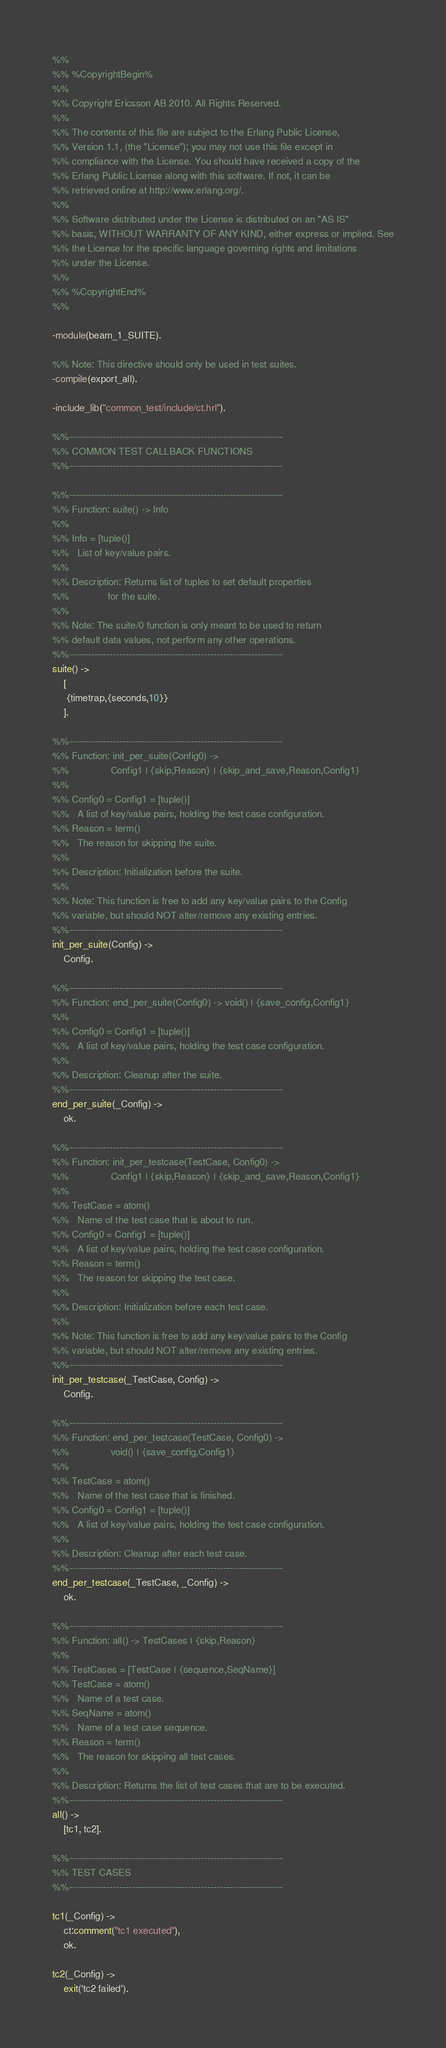<code> <loc_0><loc_0><loc_500><loc_500><_Erlang_>%%
%% %CopyrightBegin%
%%
%% Copyright Ericsson AB 2010. All Rights Reserved.
%%
%% The contents of this file are subject to the Erlang Public License,
%% Version 1.1, (the "License"); you may not use this file except in
%% compliance with the License. You should have received a copy of the
%% Erlang Public License along with this software. If not, it can be
%% retrieved online at http://www.erlang.org/.
%%
%% Software distributed under the License is distributed on an "AS IS"
%% basis, WITHOUT WARRANTY OF ANY KIND, either express or implied. See
%% the License for the specific language governing rights and limitations
%% under the License.
%%
%% %CopyrightEnd%
%%

-module(beam_1_SUITE).

%% Note: This directive should only be used in test suites.
-compile(export_all).

-include_lib("common_test/include/ct.hrl").

%%--------------------------------------------------------------------
%% COMMON TEST CALLBACK FUNCTIONS
%%--------------------------------------------------------------------

%%--------------------------------------------------------------------
%% Function: suite() -> Info
%%
%% Info = [tuple()]
%%   List of key/value pairs.
%%
%% Description: Returns list of tuples to set default properties
%%              for the suite.
%%
%% Note: The suite/0 function is only meant to be used to return
%% default data values, not perform any other operations.
%%--------------------------------------------------------------------
suite() ->
    [
     {timetrap,{seconds,10}}
    ].

%%--------------------------------------------------------------------
%% Function: init_per_suite(Config0) ->
%%               Config1 | {skip,Reason} | {skip_and_save,Reason,Config1}
%%
%% Config0 = Config1 = [tuple()]
%%   A list of key/value pairs, holding the test case configuration.
%% Reason = term()
%%   The reason for skipping the suite.
%%
%% Description: Initialization before the suite.
%%
%% Note: This function is free to add any key/value pairs to the Config
%% variable, but should NOT alter/remove any existing entries.
%%--------------------------------------------------------------------
init_per_suite(Config) ->
    Config.

%%--------------------------------------------------------------------
%% Function: end_per_suite(Config0) -> void() | {save_config,Config1}
%%
%% Config0 = Config1 = [tuple()]
%%   A list of key/value pairs, holding the test case configuration.
%%
%% Description: Cleanup after the suite.
%%--------------------------------------------------------------------
end_per_suite(_Config) ->
    ok.

%%--------------------------------------------------------------------
%% Function: init_per_testcase(TestCase, Config0) ->
%%               Config1 | {skip,Reason} | {skip_and_save,Reason,Config1}
%%
%% TestCase = atom()
%%   Name of the test case that is about to run.
%% Config0 = Config1 = [tuple()]
%%   A list of key/value pairs, holding the test case configuration.
%% Reason = term()
%%   The reason for skipping the test case.
%%
%% Description: Initialization before each test case.
%%
%% Note: This function is free to add any key/value pairs to the Config
%% variable, but should NOT alter/remove any existing entries.
%%--------------------------------------------------------------------
init_per_testcase(_TestCase, Config) ->
    Config.

%%--------------------------------------------------------------------
%% Function: end_per_testcase(TestCase, Config0) ->
%%               void() | {save_config,Config1}
%%
%% TestCase = atom()
%%   Name of the test case that is finished.
%% Config0 = Config1 = [tuple()]
%%   A list of key/value pairs, holding the test case configuration.
%%
%% Description: Cleanup after each test case.
%%--------------------------------------------------------------------
end_per_testcase(_TestCase, _Config) ->
    ok.

%%--------------------------------------------------------------------
%% Function: all() -> TestCases | {skip,Reason}
%%
%% TestCases = [TestCase | {sequence,SeqName}]
%% TestCase = atom()
%%   Name of a test case.
%% SeqName = atom()
%%   Name of a test case sequence.
%% Reason = term()
%%   The reason for skipping all test cases.
%%
%% Description: Returns the list of test cases that are to be executed.
%%--------------------------------------------------------------------
all() ->
    [tc1, tc2].

%%--------------------------------------------------------------------
%% TEST CASES
%%--------------------------------------------------------------------

tc1(_Config) ->
    ct:comment("tc1 executed"),
    ok.

tc2(_Config) ->
    exit('tc2 failed').
</code> 